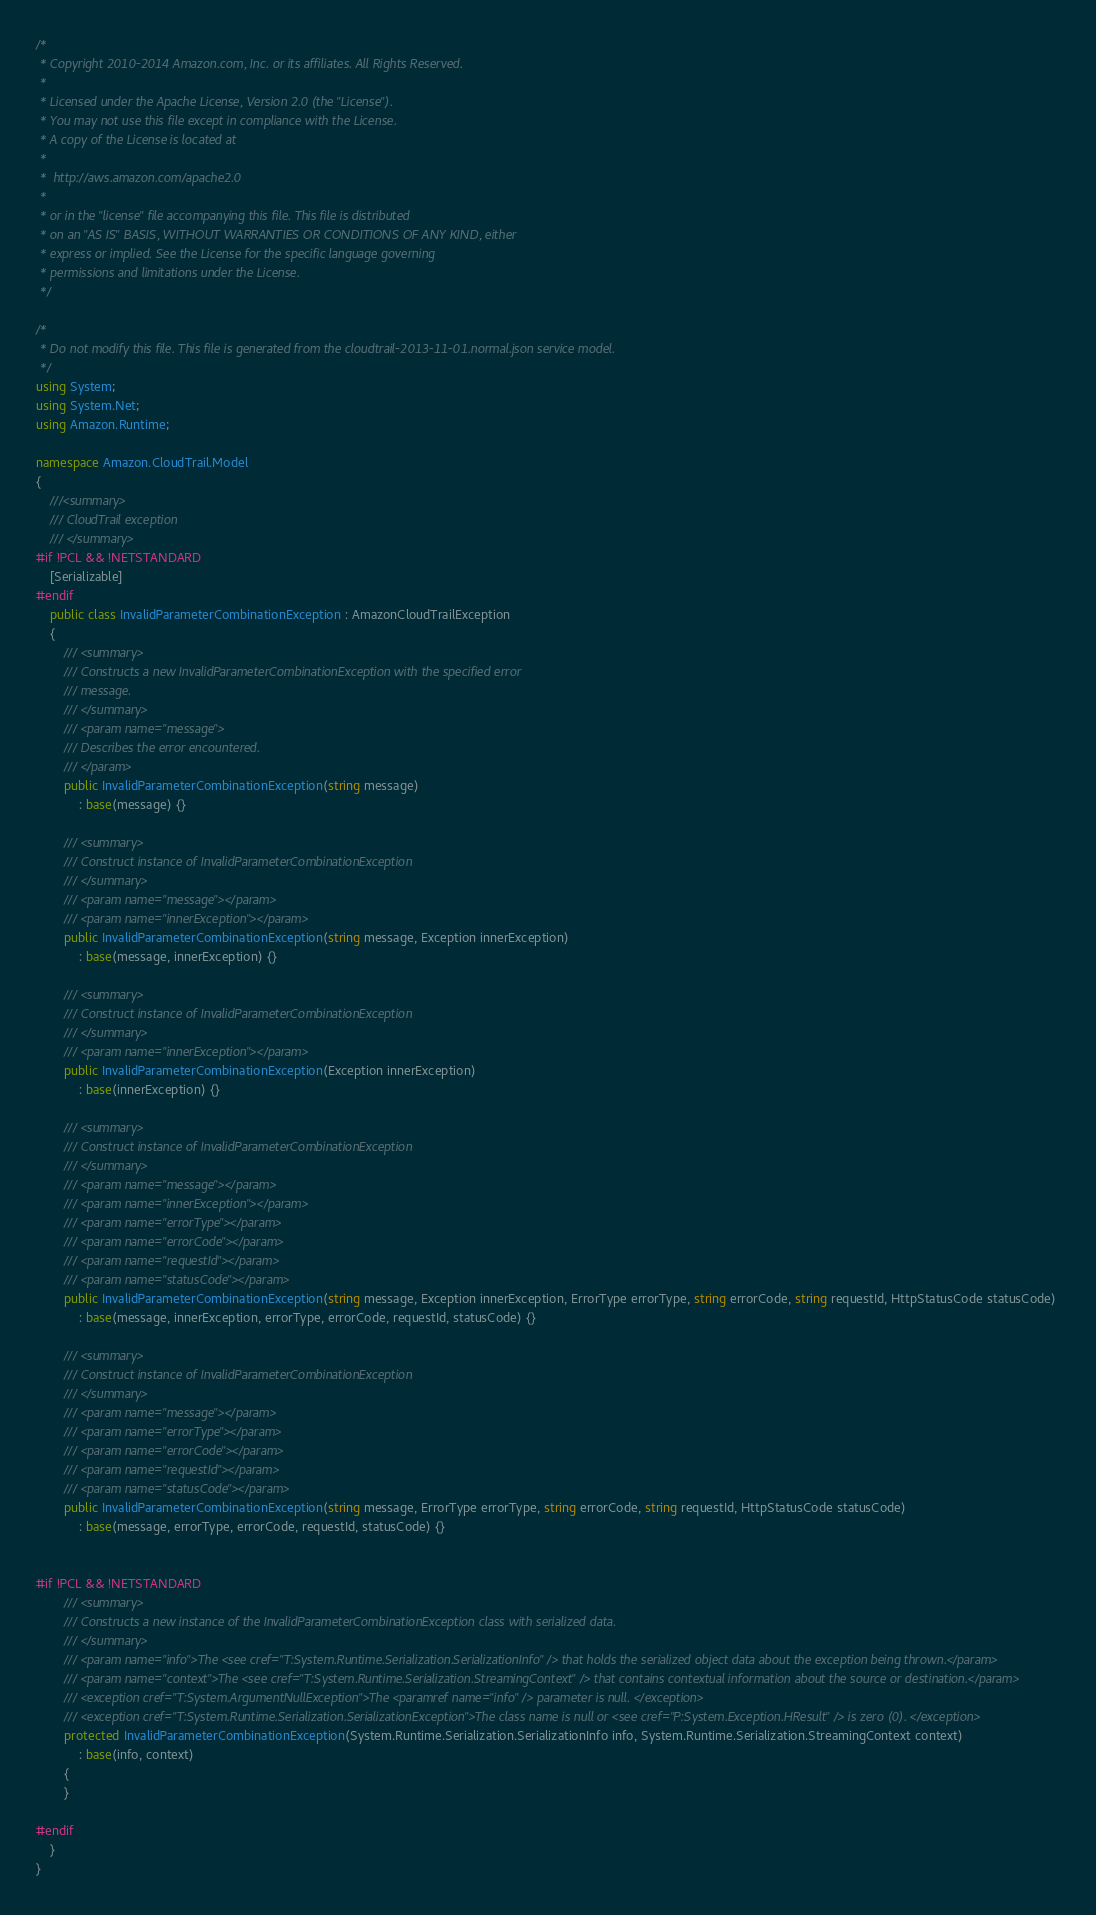Convert code to text. <code><loc_0><loc_0><loc_500><loc_500><_C#_>/*
 * Copyright 2010-2014 Amazon.com, Inc. or its affiliates. All Rights Reserved.
 * 
 * Licensed under the Apache License, Version 2.0 (the "License").
 * You may not use this file except in compliance with the License.
 * A copy of the License is located at
 * 
 *  http://aws.amazon.com/apache2.0
 * 
 * or in the "license" file accompanying this file. This file is distributed
 * on an "AS IS" BASIS, WITHOUT WARRANTIES OR CONDITIONS OF ANY KIND, either
 * express or implied. See the License for the specific language governing
 * permissions and limitations under the License.
 */

/*
 * Do not modify this file. This file is generated from the cloudtrail-2013-11-01.normal.json service model.
 */
using System;
using System.Net;
using Amazon.Runtime;

namespace Amazon.CloudTrail.Model
{
    ///<summary>
    /// CloudTrail exception
    /// </summary>
#if !PCL && !NETSTANDARD
    [Serializable]
#endif
    public class InvalidParameterCombinationException : AmazonCloudTrailException 
    {
        /// <summary>
        /// Constructs a new InvalidParameterCombinationException with the specified error
        /// message.
        /// </summary>
        /// <param name="message">
        /// Describes the error encountered.
        /// </param>
        public InvalidParameterCombinationException(string message) 
            : base(message) {}
          
        /// <summary>
        /// Construct instance of InvalidParameterCombinationException
        /// </summary>
        /// <param name="message"></param>
        /// <param name="innerException"></param>
        public InvalidParameterCombinationException(string message, Exception innerException) 
            : base(message, innerException) {}
            
        /// <summary>
        /// Construct instance of InvalidParameterCombinationException
        /// </summary>
        /// <param name="innerException"></param>
        public InvalidParameterCombinationException(Exception innerException) 
            : base(innerException) {}
            
        /// <summary>
        /// Construct instance of InvalidParameterCombinationException
        /// </summary>
        /// <param name="message"></param>
        /// <param name="innerException"></param>
        /// <param name="errorType"></param>
        /// <param name="errorCode"></param>
        /// <param name="requestId"></param>
        /// <param name="statusCode"></param>
        public InvalidParameterCombinationException(string message, Exception innerException, ErrorType errorType, string errorCode, string requestId, HttpStatusCode statusCode) 
            : base(message, innerException, errorType, errorCode, requestId, statusCode) {}

        /// <summary>
        /// Construct instance of InvalidParameterCombinationException
        /// </summary>
        /// <param name="message"></param>
        /// <param name="errorType"></param>
        /// <param name="errorCode"></param>
        /// <param name="requestId"></param>
        /// <param name="statusCode"></param>
        public InvalidParameterCombinationException(string message, ErrorType errorType, string errorCode, string requestId, HttpStatusCode statusCode) 
            : base(message, errorType, errorCode, requestId, statusCode) {}


#if !PCL && !NETSTANDARD
        /// <summary>
        /// Constructs a new instance of the InvalidParameterCombinationException class with serialized data.
        /// </summary>
        /// <param name="info">The <see cref="T:System.Runtime.Serialization.SerializationInfo" /> that holds the serialized object data about the exception being thrown.</param>
        /// <param name="context">The <see cref="T:System.Runtime.Serialization.StreamingContext" /> that contains contextual information about the source or destination.</param>
        /// <exception cref="T:System.ArgumentNullException">The <paramref name="info" /> parameter is null. </exception>
        /// <exception cref="T:System.Runtime.Serialization.SerializationException">The class name is null or <see cref="P:System.Exception.HResult" /> is zero (0). </exception>
        protected InvalidParameterCombinationException(System.Runtime.Serialization.SerializationInfo info, System.Runtime.Serialization.StreamingContext context)
            : base(info, context)
        {
        }

#endif
    }
}</code> 